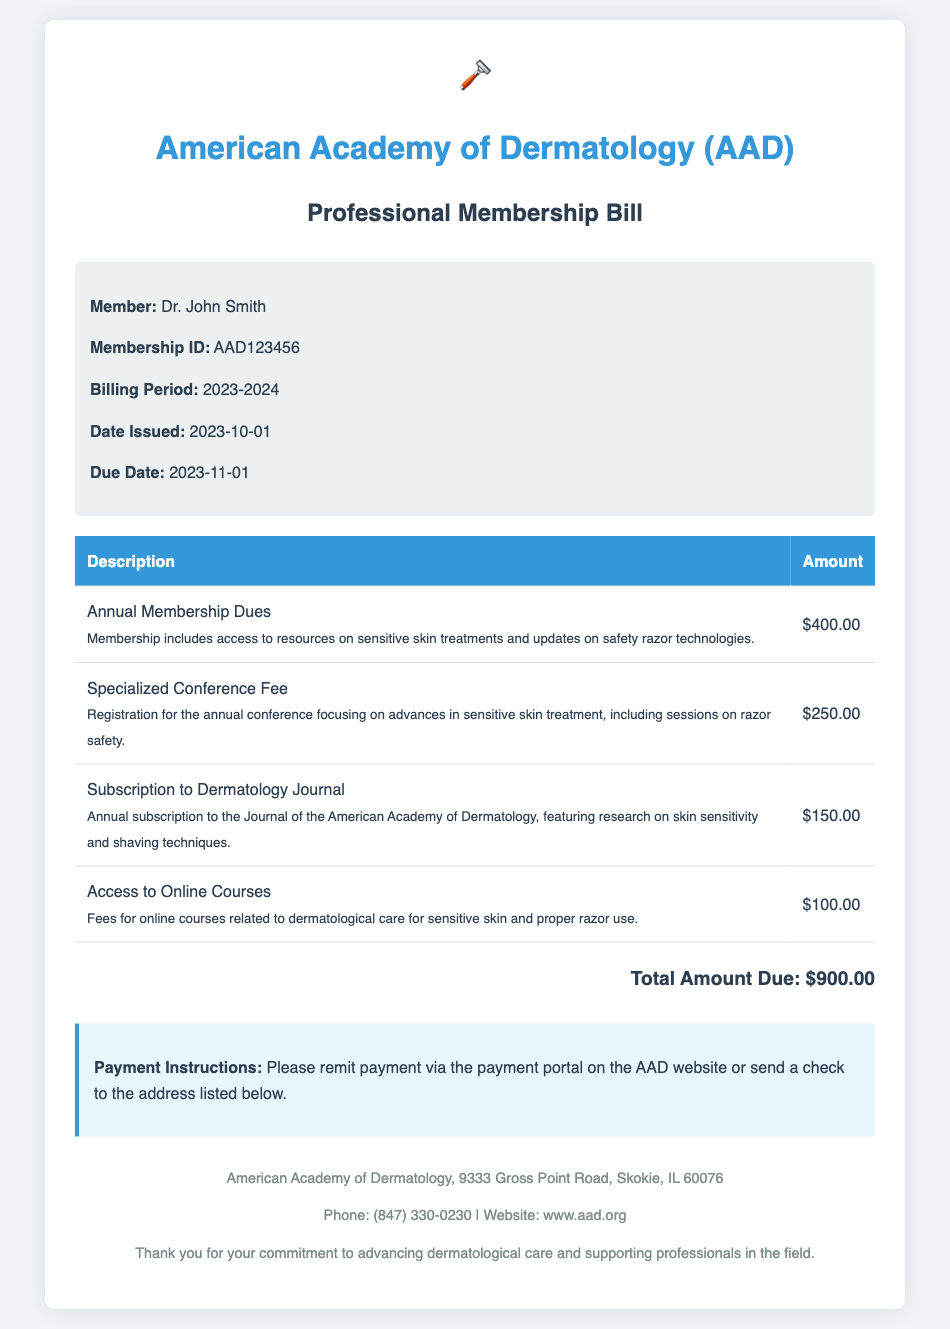What is the member's name? The member's name is clearly stated in the member info section of the document.
Answer: Dr. John Smith What is the membership ID? The membership ID is provided right under the member's name in the document.
Answer: AAD123456 What is the total amount due? The total amount due is presented at the end of the bill details section.
Answer: $900.00 What is the due date for the payment? The due date is specifically mentioned in the member info section of the document.
Answer: 2023-11-01 What is included in the annual membership dues? The document specifies that membership includes access to resources on sensitive skin treatments and updates on safety razor technologies.
Answer: Access to resources on sensitive skin treatments and updates on safety razor technologies How much is the specialized conference fee? The fee for the specialized conference is listed in the bill details table.
Answer: $250.00 What type of subscription is included in the bill? The document mentions an annual subscription to a specific dermatology journal.
Answer: Subscription to Dermatology Journal Why does the document mention razor safety? Razor safety is mentioned as part of the specialized conference and online courses related to sensitive skin treatment.
Answer: Specialized conference and online courses Where should the payment be sent? The payment instructions indicate the method for remitting payment in the document.
Answer: AAD website or send a check to the address 